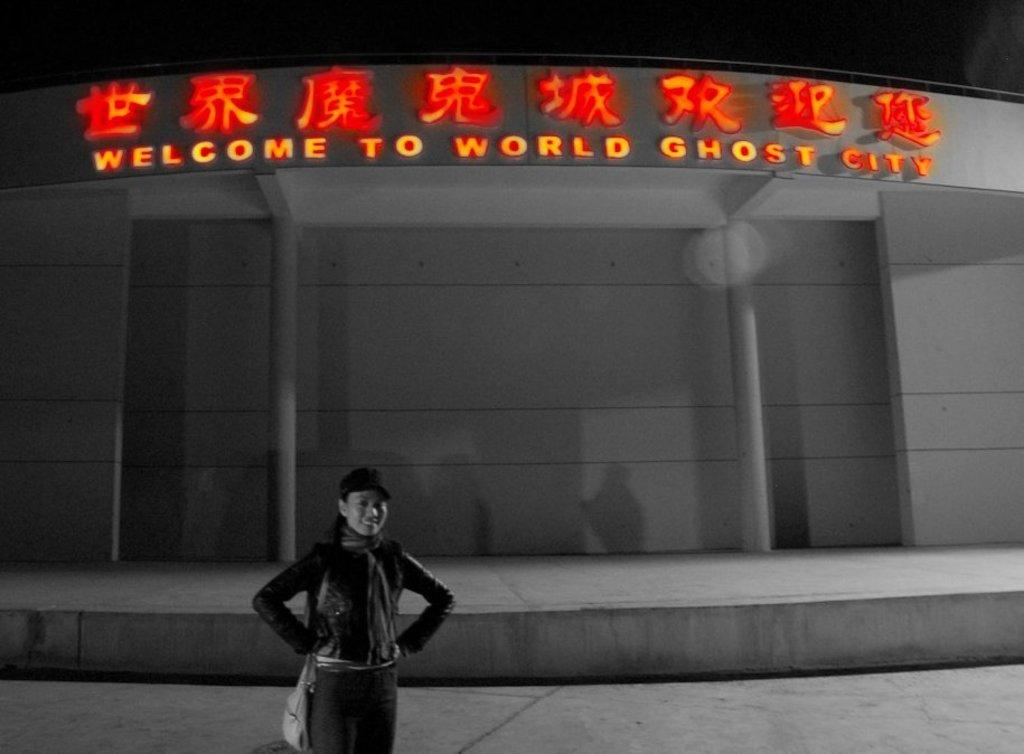Who is present in the image? There is a woman in the image. What is the woman doing in the image? The woman is standing and smiling. What is the woman wearing in the image? The woman is wearing a bag. What can be seen in the background of the image? There is a building in the background of the image. What is written or displayed on a wall in the image? There is text on a wall in the image. Can you see a bee buzzing around the woman's thumb in the image? There is no bee or thumb present in the image. 